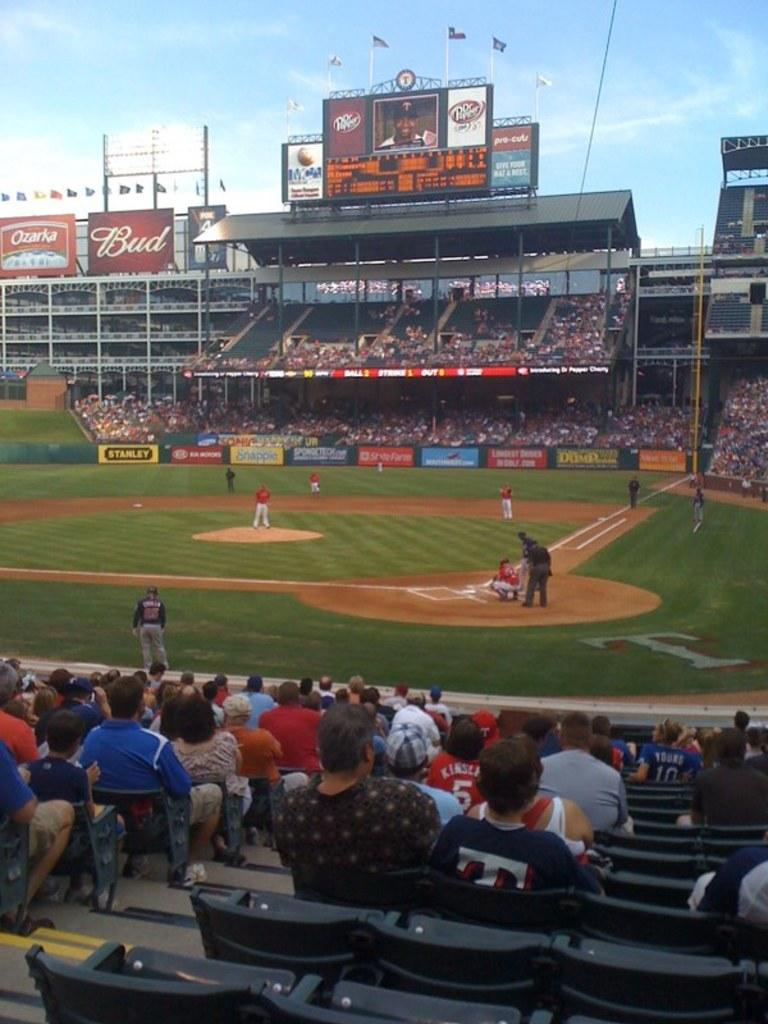Provide a one-sentence caption for the provided image. Fans are watching a baseball game in a stadium filled with ads for products like Bud. 